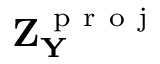Convert formula to latex. <formula><loc_0><loc_0><loc_500><loc_500>Z _ { Y } ^ { p r o j }</formula> 